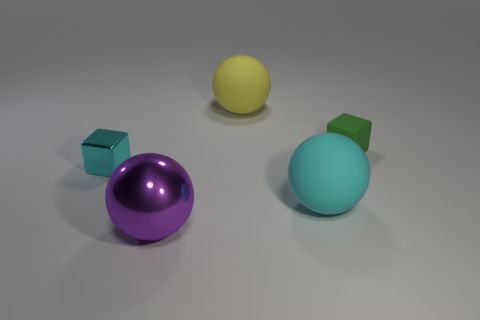Can you describe the surface on which the objects are placed? The objects are resting upon a smooth, matte surface that appears to be of a neutral color, likely grey, which gives off a sense of a nondescript or infinite space. 